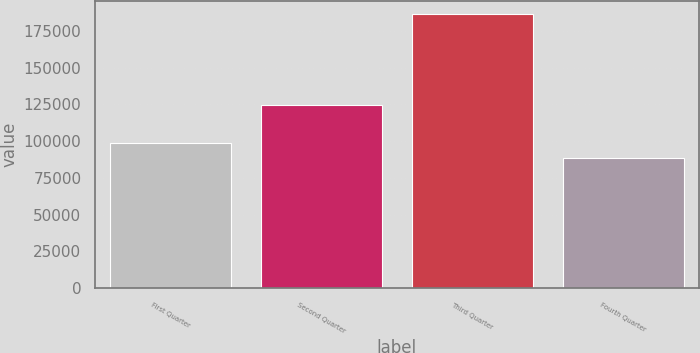Convert chart to OTSL. <chart><loc_0><loc_0><loc_500><loc_500><bar_chart><fcel>First Quarter<fcel>Second Quarter<fcel>Third Quarter<fcel>Fourth Quarter<nl><fcel>98543<fcel>124479<fcel>186284<fcel>88794<nl></chart> 